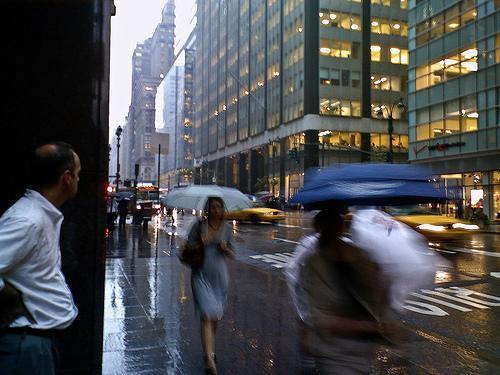How many umbrellas are shown?
Give a very brief answer. 2. 